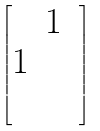<formula> <loc_0><loc_0><loc_500><loc_500>\begin{bmatrix} & 1 & \\ 1 & & \\ & & \end{bmatrix}</formula> 